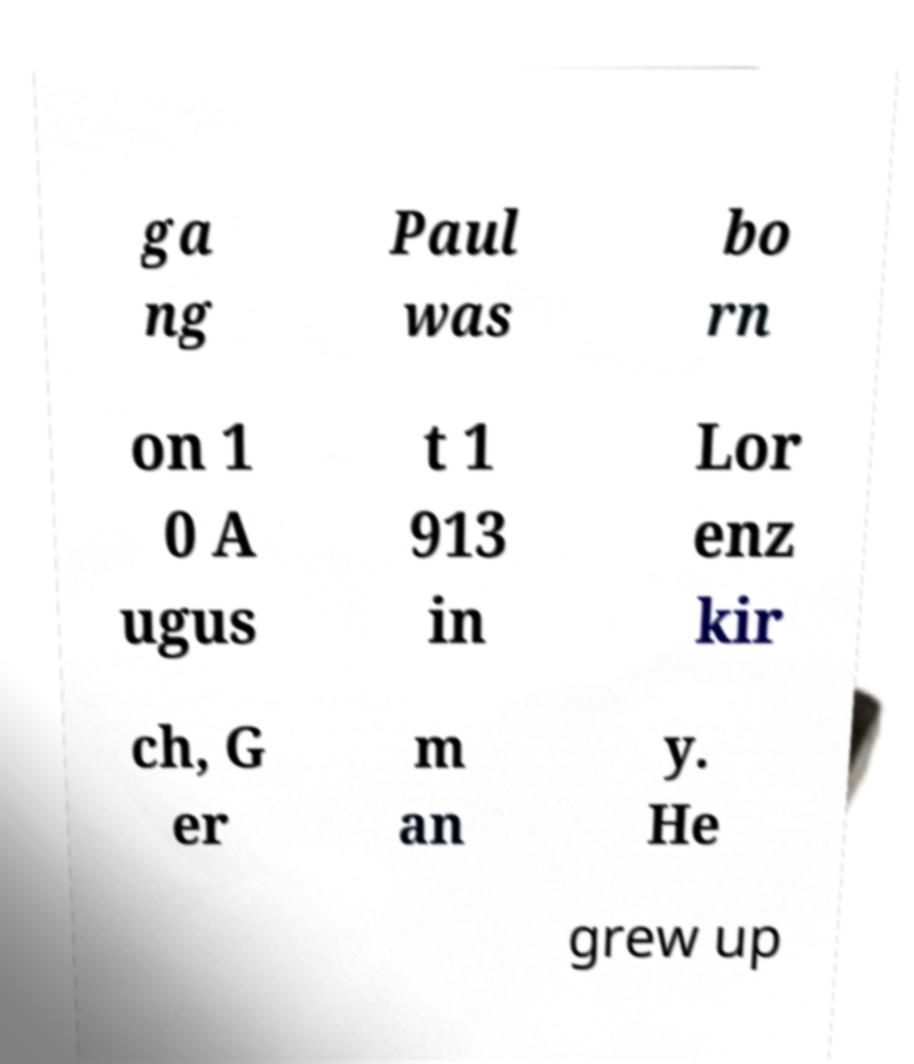Please identify and transcribe the text found in this image. ga ng Paul was bo rn on 1 0 A ugus t 1 913 in Lor enz kir ch, G er m an y. He grew up 